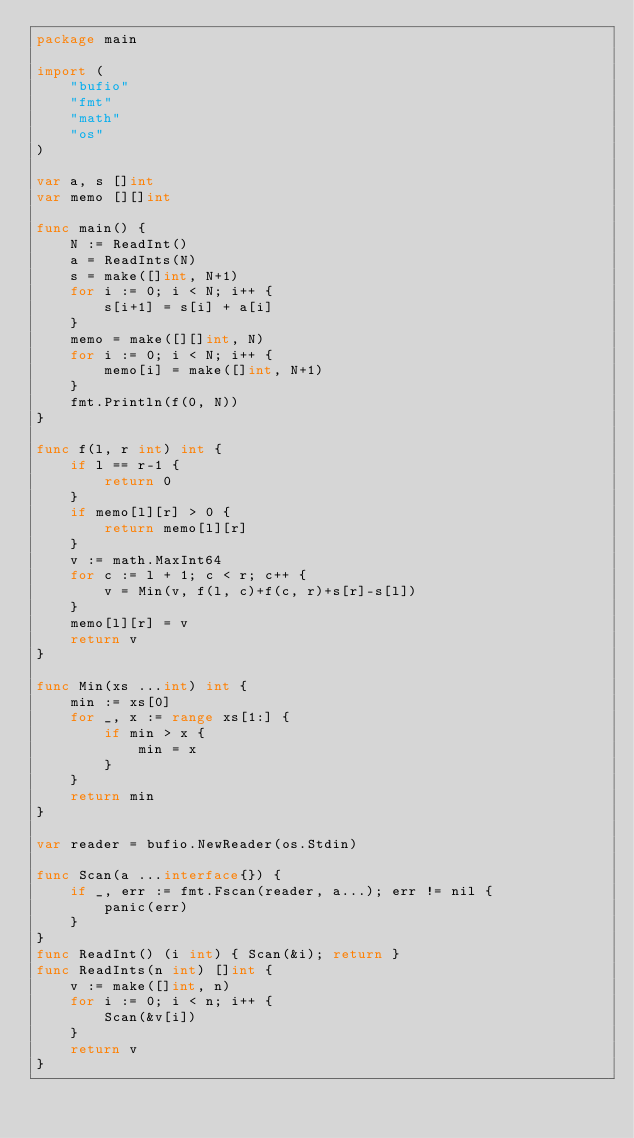<code> <loc_0><loc_0><loc_500><loc_500><_Go_>package main

import (
	"bufio"
	"fmt"
	"math"
	"os"
)

var a, s []int
var memo [][]int

func main() {
	N := ReadInt()
	a = ReadInts(N)
	s = make([]int, N+1)
	for i := 0; i < N; i++ {
		s[i+1] = s[i] + a[i]
	}
	memo = make([][]int, N)
	for i := 0; i < N; i++ {
		memo[i] = make([]int, N+1)
	}
	fmt.Println(f(0, N))
}

func f(l, r int) int {
	if l == r-1 {
		return 0
	}
	if memo[l][r] > 0 {
		return memo[l][r]
	}
	v := math.MaxInt64
	for c := l + 1; c < r; c++ {
		v = Min(v, f(l, c)+f(c, r)+s[r]-s[l])
	}
	memo[l][r] = v
	return v
}

func Min(xs ...int) int {
	min := xs[0]
	for _, x := range xs[1:] {
		if min > x {
			min = x
		}
	}
	return min
}

var reader = bufio.NewReader(os.Stdin)

func Scan(a ...interface{}) {
	if _, err := fmt.Fscan(reader, a...); err != nil {
		panic(err)
	}
}
func ReadInt() (i int) { Scan(&i); return }
func ReadInts(n int) []int {
	v := make([]int, n)
	for i := 0; i < n; i++ {
		Scan(&v[i])
	}
	return v
}
</code> 